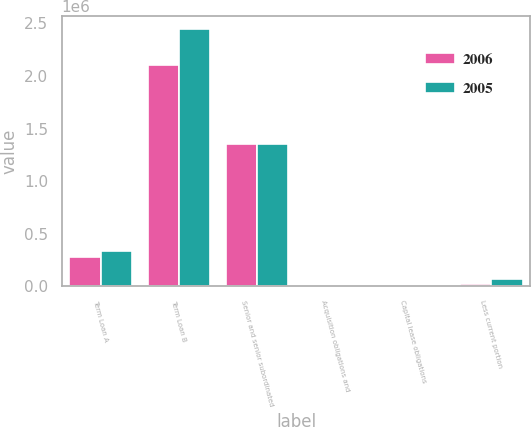Convert chart. <chart><loc_0><loc_0><loc_500><loc_500><stacked_bar_chart><ecel><fcel>Term Loan A<fcel>Term Loan B<fcel>Senior and senior subordinated<fcel>Acquisition obligations and<fcel>Capital lease obligations<fcel>Less current portion<nl><fcel>2006<fcel>279250<fcel>2.10588e+06<fcel>1.35e+06<fcel>9197<fcel>6929<fcel>20871<nl><fcel>2005<fcel>341250<fcel>2.44388e+06<fcel>1.35e+06<fcel>14757<fcel>7320<fcel>71767<nl></chart> 